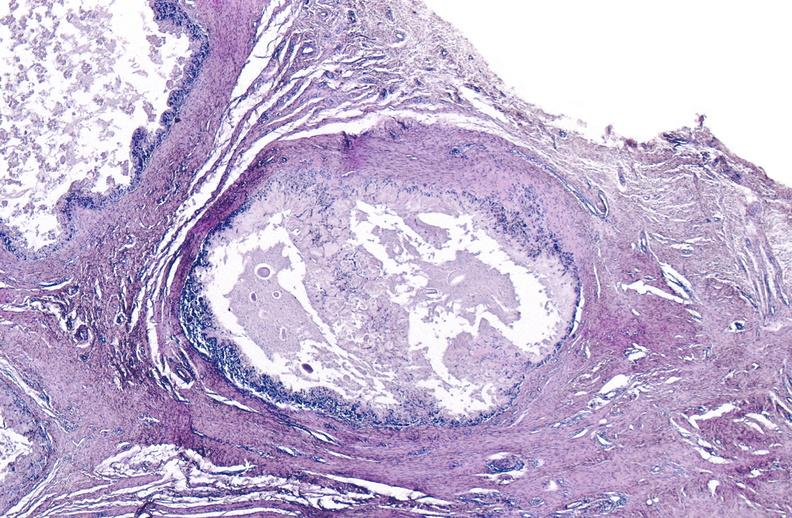what does this image show?
Answer the question using a single word or phrase. Gout 